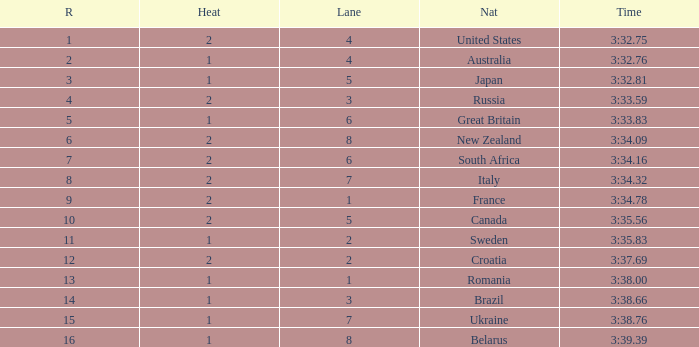Can you tell me the Time that has the Heat of 1, and the Lane of 2? 3:35.83. 